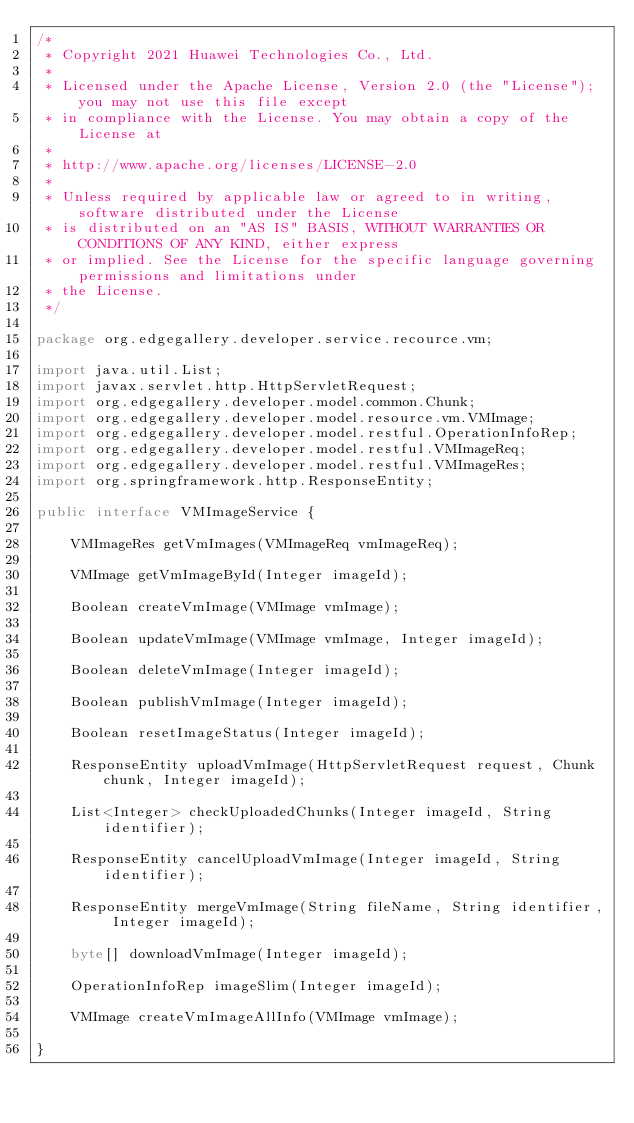<code> <loc_0><loc_0><loc_500><loc_500><_Java_>/*
 * Copyright 2021 Huawei Technologies Co., Ltd.
 *
 * Licensed under the Apache License, Version 2.0 (the "License"); you may not use this file except
 * in compliance with the License. You may obtain a copy of the License at
 *
 * http://www.apache.org/licenses/LICENSE-2.0
 *
 * Unless required by applicable law or agreed to in writing, software distributed under the License
 * is distributed on an "AS IS" BASIS, WITHOUT WARRANTIES OR CONDITIONS OF ANY KIND, either express
 * or implied. See the License for the specific language governing permissions and limitations under
 * the License.
 */

package org.edgegallery.developer.service.recource.vm;

import java.util.List;
import javax.servlet.http.HttpServletRequest;
import org.edgegallery.developer.model.common.Chunk;
import org.edgegallery.developer.model.resource.vm.VMImage;
import org.edgegallery.developer.model.restful.OperationInfoRep;
import org.edgegallery.developer.model.restful.VMImageReq;
import org.edgegallery.developer.model.restful.VMImageRes;
import org.springframework.http.ResponseEntity;

public interface VMImageService {

    VMImageRes getVmImages(VMImageReq vmImageReq);

    VMImage getVmImageById(Integer imageId);

    Boolean createVmImage(VMImage vmImage);

    Boolean updateVmImage(VMImage vmImage, Integer imageId);

    Boolean deleteVmImage(Integer imageId);

    Boolean publishVmImage(Integer imageId);

    Boolean resetImageStatus(Integer imageId);

    ResponseEntity uploadVmImage(HttpServletRequest request, Chunk chunk, Integer imageId);

    List<Integer> checkUploadedChunks(Integer imageId, String identifier);

    ResponseEntity cancelUploadVmImage(Integer imageId, String identifier);

    ResponseEntity mergeVmImage(String fileName, String identifier, Integer imageId);

    byte[] downloadVmImage(Integer imageId);

    OperationInfoRep imageSlim(Integer imageId);

    VMImage createVmImageAllInfo(VMImage vmImage);

}
</code> 